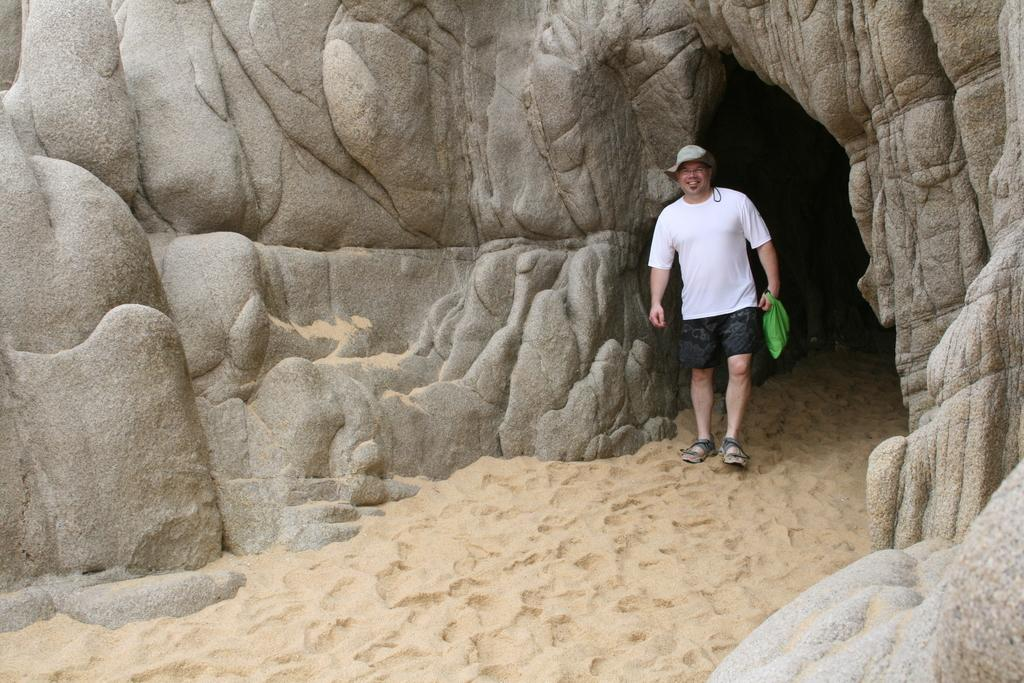What is the main feature of the image? There is a cave in the image. Can you describe the person in the image? The person is wearing glasses and a cap, and is holding a bag. What type of terrain is visible at the bottom of the image? There is sand at the bottom of the image. How many oranges are being carried by the wren in the image? There is no wren or oranges present in the image. What is the cause of death for the person in the image? There is no indication of death or any cause of death in the image. 